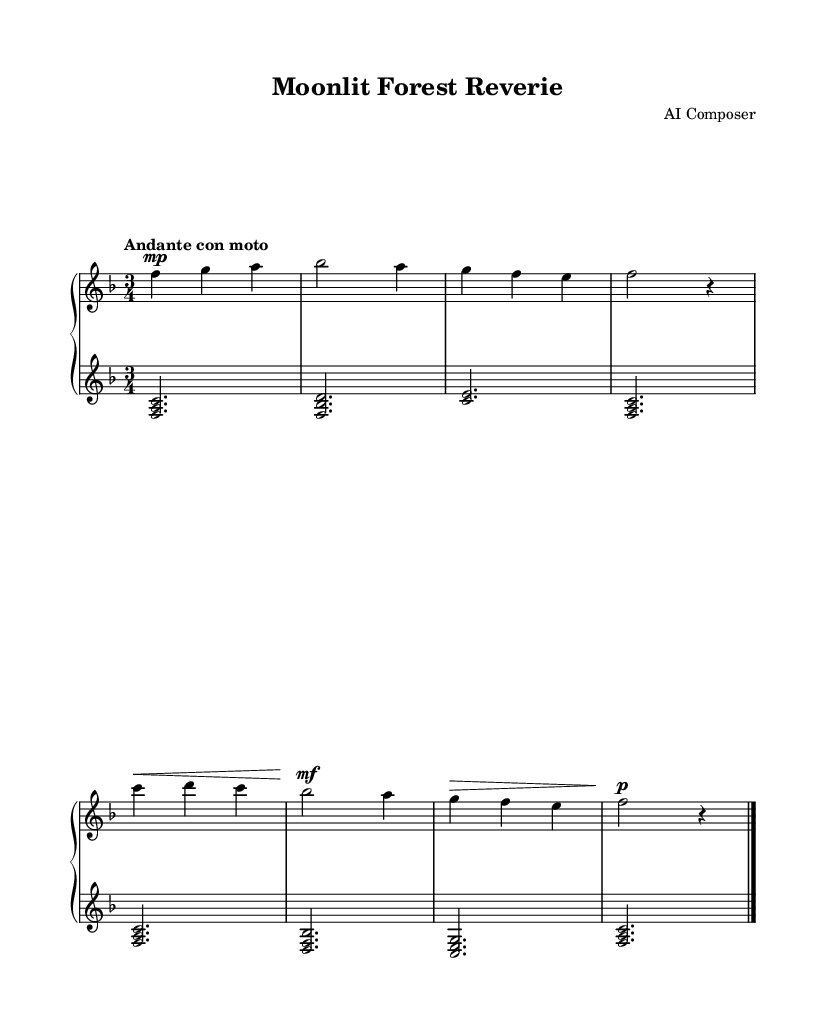What is the key signature of this music? The key signature is F major, which has one flat (B flat). This is determined by looking at the key signature at the beginning of the staff on the left side of the sheet music.
Answer: F major What is the time signature of this piece? The time signature is 3/4, indicated at the beginning of the staff. This means there are three beats per measure, and the quarter note gets one beat.
Answer: 3/4 What is the tempo marking for this piece? The tempo marking is "Andante con moto," which suggests a moderately slow and flowing pace, characterized by a steady walking speed with some movement. This can be found written above the staff at the start of the music.
Answer: Andante con moto How many measures are in the piece? There are 8 measures within the two staffs combined. By counting the vertical bar lines on the staff, we determine the total number of measures in the piece.
Answer: 8 What dynamic marking is indicated at the beginning of the upper staff? The dynamic marking is "mp," which stands for mezzo-piano, meaning moderately soft. This marking is placed before the first note in the upper staff to indicate the volume at which to play.
Answer: mp Which section contains an accented note? The section with an accented note is the second half of the second measure (g4). The accent symbol is placed above the note, indicating that it should be played with emphasis.
Answer: Second measure 